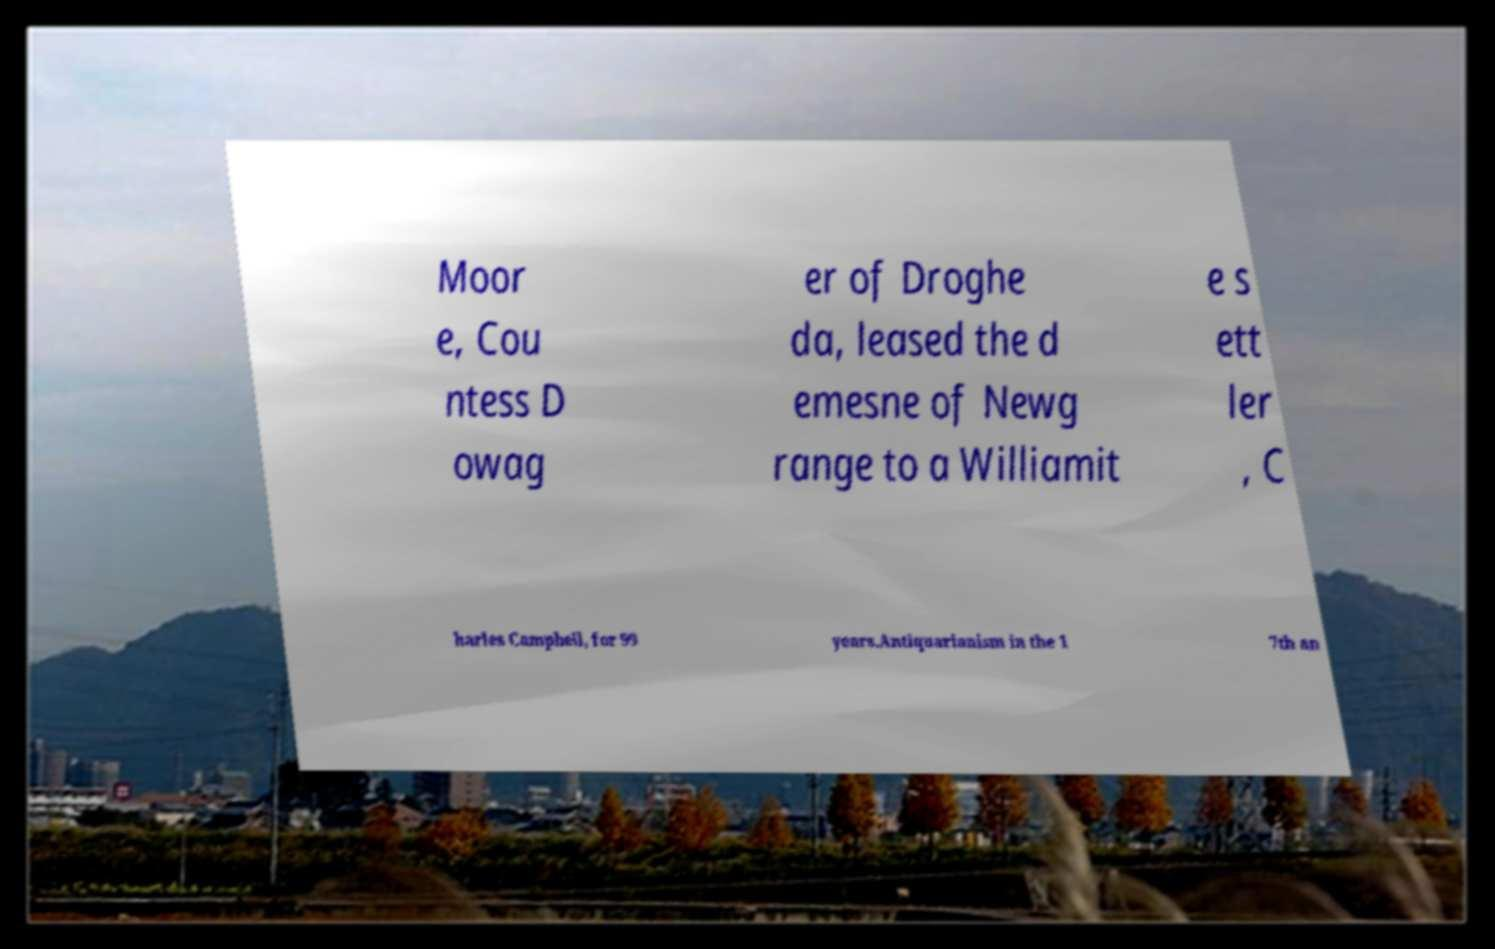I need the written content from this picture converted into text. Can you do that? Moor e, Cou ntess D owag er of Droghe da, leased the d emesne of Newg range to a Williamit e s ett ler , C harles Campbell, for 99 years.Antiquarianism in the 1 7th an 